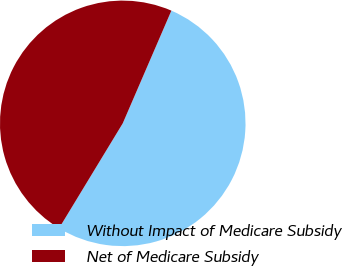Convert chart to OTSL. <chart><loc_0><loc_0><loc_500><loc_500><pie_chart><fcel>Without Impact of Medicare Subsidy<fcel>Net of Medicare Subsidy<nl><fcel>52.2%<fcel>47.8%<nl></chart> 